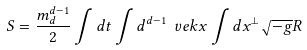<formula> <loc_0><loc_0><loc_500><loc_500>S = \frac { m _ { d } ^ { d - 1 } } { 2 } \int d t \int d ^ { d - 1 } \ v e k { x } \int d x ^ { \perp } \sqrt { - g } R</formula> 